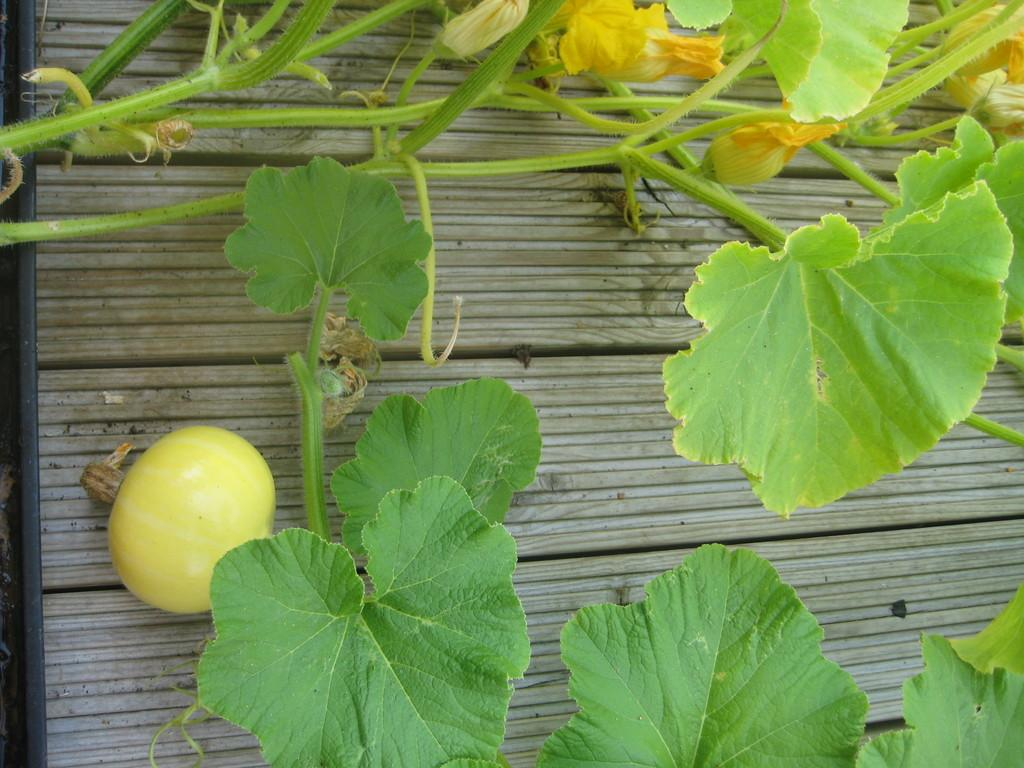What is placed on the wooden surface in the image? There is a plant and vegetables on the wooden surface. Can you describe the plant on the wooden surface? The provided facts do not give specific details about the plant, but it is present on the wooden surface. What type of vegetables are on the wooden surface? The provided facts do not specify the type of vegetables, but they are present on the wooden surface. Where is the zipper located on the wooden surface? There is no zipper present on the wooden surface in the image. What type of fruit can be seen growing on the plant in the image? The provided facts do not mention any fruit growing on the plant, and there is no fruit visible in the image. 